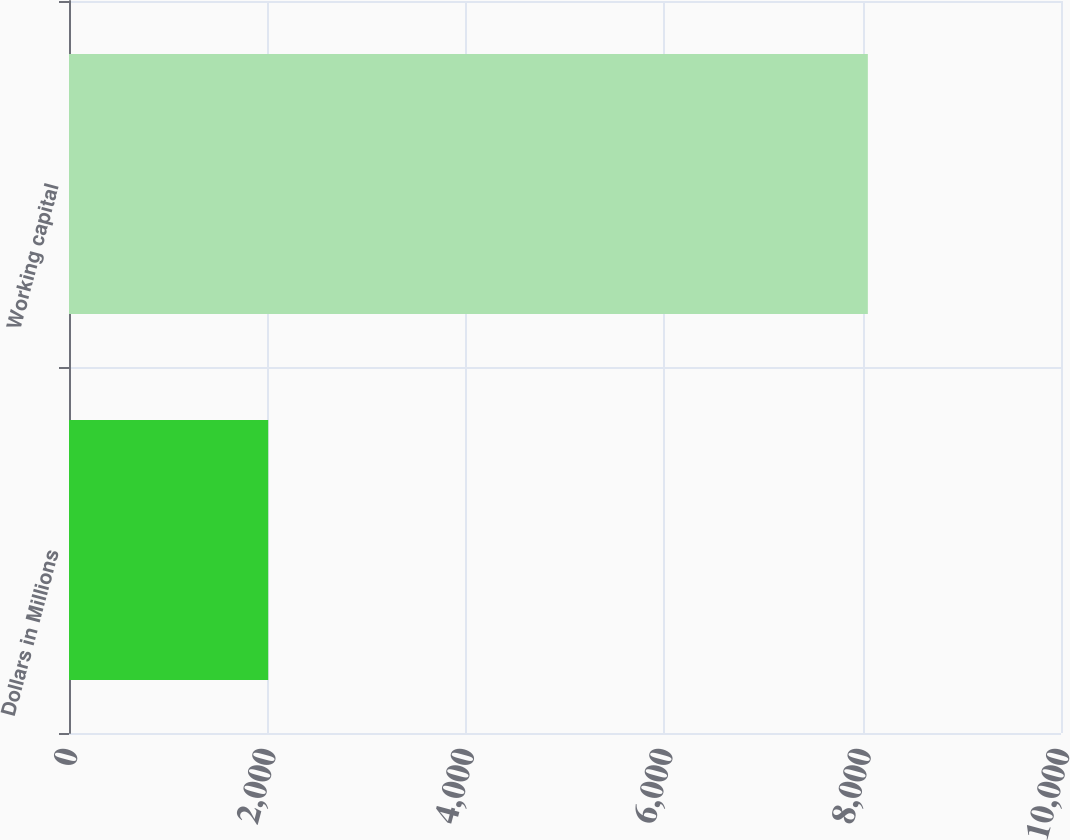<chart> <loc_0><loc_0><loc_500><loc_500><bar_chart><fcel>Dollars in Millions<fcel>Working capital<nl><fcel>2008<fcel>8053<nl></chart> 